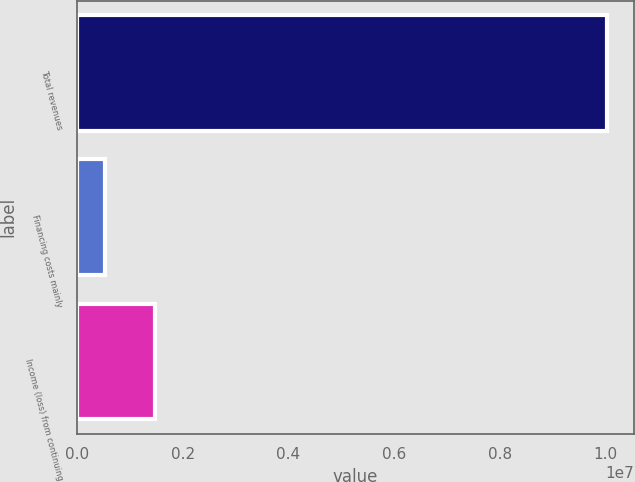Convert chart. <chart><loc_0><loc_0><loc_500><loc_500><bar_chart><fcel>Total revenues<fcel>Financing costs mainly<fcel>Income (loss) from continuing<nl><fcel>1.00342e+07<fcel>528845<fcel>1.47938e+06<nl></chart> 